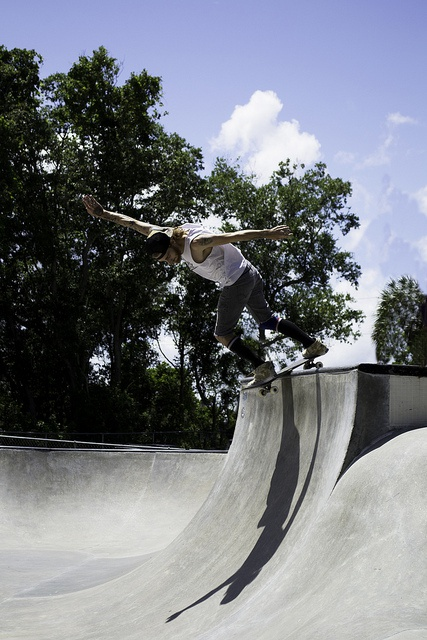Describe the objects in this image and their specific colors. I can see people in darkgray, black, gray, and lightgray tones and skateboard in darkgray, black, gray, and lightgray tones in this image. 